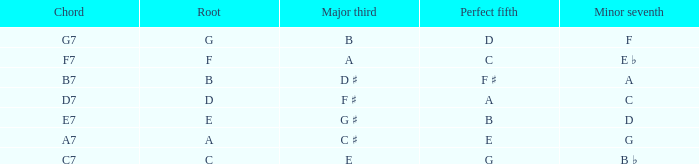What is the Perfect fifth with a Minor that is seventh of d? B. 